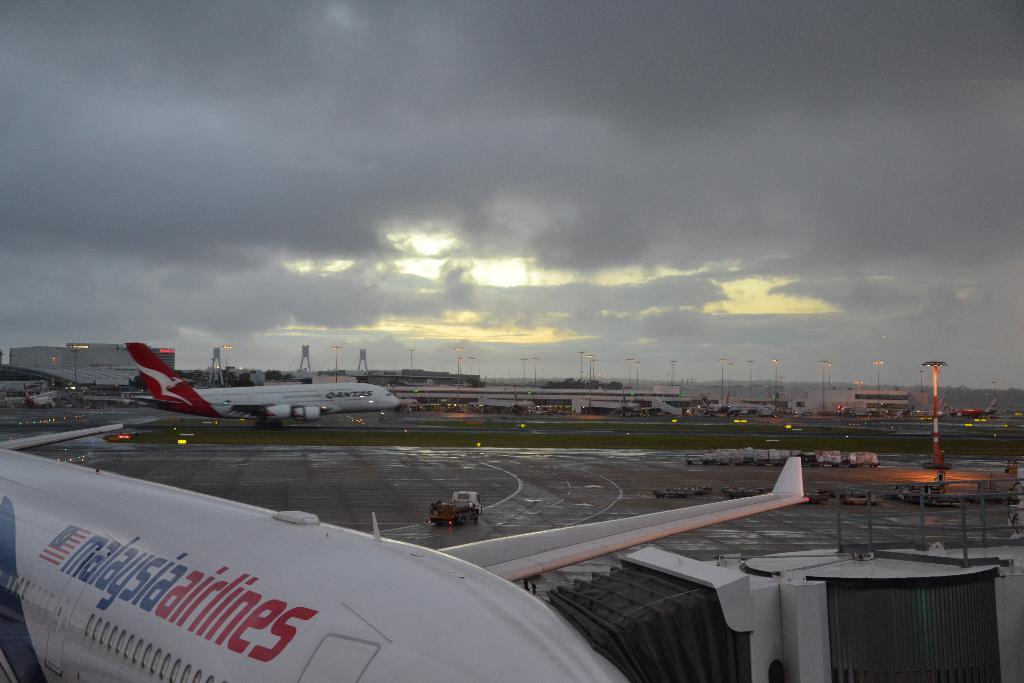What airline is this?
Give a very brief answer. Malaysia airlines. Does the plane in the foreground belong to american airlines?
Make the answer very short. No. 